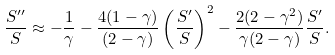<formula> <loc_0><loc_0><loc_500><loc_500>\frac { S ^ { \prime \prime } } { S } \approx - \frac { 1 } { \gamma } - \frac { 4 ( 1 - \gamma ) } { ( 2 - \gamma ) } \left ( \frac { S ^ { \prime } } { S } \right ) ^ { 2 } - \frac { 2 ( 2 - \gamma ^ { 2 } ) } { \gamma ( 2 - \gamma ) } \frac { S ^ { \prime } } { S } .</formula> 